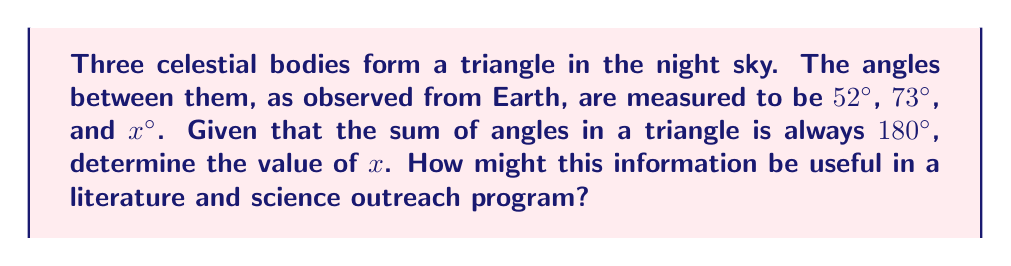Can you solve this math problem? Let's approach this step-by-step:

1) First, recall the fundamental property of triangles: the sum of all angles in a triangle is always 180°. This is true for any triangle, including those formed by celestial bodies in the sky.

2) We can express this as an equation:
   $$ 52° + 73° + x° = 180° $$

3) To solve for x, we need to isolate it on one side of the equation:
   $$ x° = 180° - (52° + 73°) $$

4) Simplify the right side:
   $$ x° = 180° - 125° = 55° $$

5) Therefore, the third angle x is 55°.

In a literature and science outreach program, this problem could be used to demonstrate the intersection of astronomy and geometry. It shows how basic geometric principles apply even to vast cosmic scales, linking the abstract math of triangles to the tangible observation of stars or planets. This could be tied to discussions of celestial navigation in literature (like in "Moby Dick" or "The Life of Pi") or to the history of using geometry in astronomical observations (like the ancient Greek astronomers or Islamic scholars of the Golden Age).
Answer: $x = 55°$ 